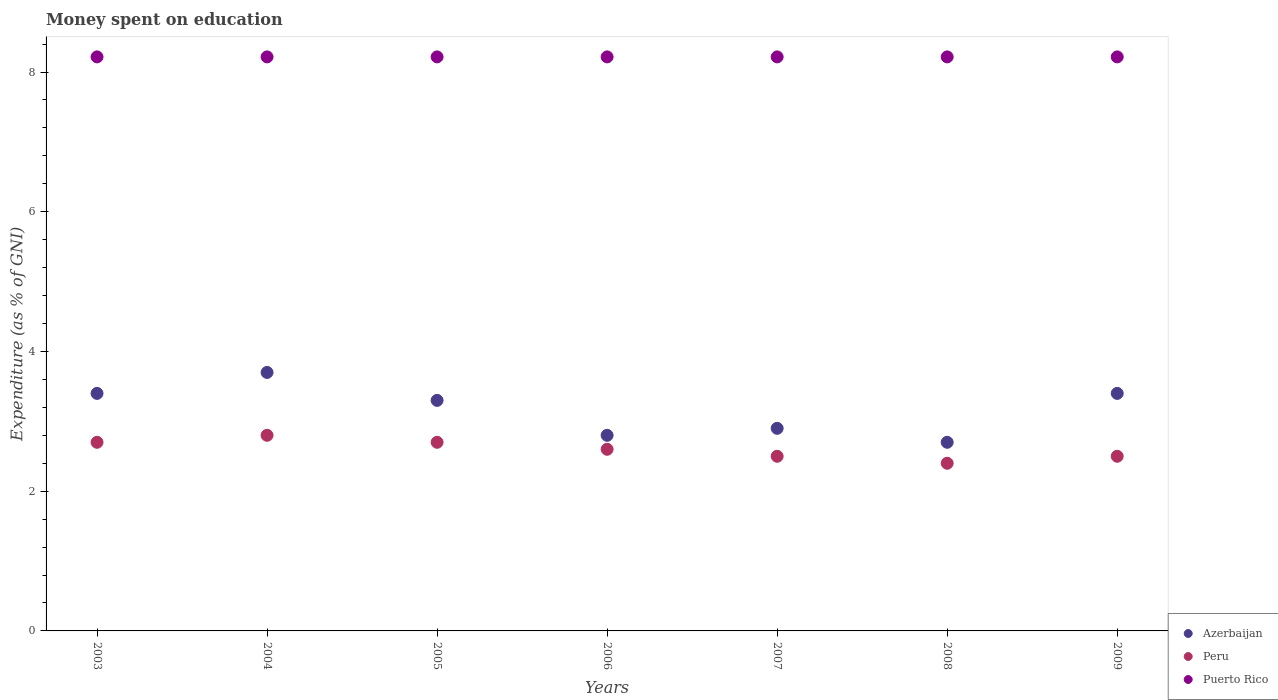Is the number of dotlines equal to the number of legend labels?
Make the answer very short. Yes. What is the amount of money spent on education in Puerto Rico in 2009?
Your answer should be compact. 8.22. Across all years, what is the maximum amount of money spent on education in Puerto Rico?
Your answer should be very brief. 8.22. Across all years, what is the minimum amount of money spent on education in Azerbaijan?
Your answer should be very brief. 2.7. In which year was the amount of money spent on education in Peru maximum?
Your answer should be compact. 2004. In which year was the amount of money spent on education in Azerbaijan minimum?
Your response must be concise. 2008. What is the difference between the amount of money spent on education in Azerbaijan in 2006 and the amount of money spent on education in Puerto Rico in 2003?
Provide a short and direct response. -5.42. What is the average amount of money spent on education in Puerto Rico per year?
Your answer should be very brief. 8.22. In the year 2007, what is the difference between the amount of money spent on education in Peru and amount of money spent on education in Puerto Rico?
Ensure brevity in your answer.  -5.72. In how many years, is the amount of money spent on education in Peru greater than 4.8 %?
Offer a terse response. 0. What is the ratio of the amount of money spent on education in Peru in 2004 to that in 2005?
Ensure brevity in your answer.  1.04. Is the difference between the amount of money spent on education in Peru in 2003 and 2008 greater than the difference between the amount of money spent on education in Puerto Rico in 2003 and 2008?
Provide a succinct answer. Yes. What is the difference between the highest and the second highest amount of money spent on education in Azerbaijan?
Ensure brevity in your answer.  0.3. What is the difference between the highest and the lowest amount of money spent on education in Peru?
Give a very brief answer. 0.4. Is the amount of money spent on education in Peru strictly greater than the amount of money spent on education in Azerbaijan over the years?
Make the answer very short. No. How many dotlines are there?
Offer a terse response. 3. How many years are there in the graph?
Offer a terse response. 7. What is the difference between two consecutive major ticks on the Y-axis?
Your answer should be very brief. 2. Are the values on the major ticks of Y-axis written in scientific E-notation?
Ensure brevity in your answer.  No. Does the graph contain any zero values?
Give a very brief answer. No. How many legend labels are there?
Provide a succinct answer. 3. What is the title of the graph?
Ensure brevity in your answer.  Money spent on education. Does "Finland" appear as one of the legend labels in the graph?
Your answer should be very brief. No. What is the label or title of the X-axis?
Ensure brevity in your answer.  Years. What is the label or title of the Y-axis?
Give a very brief answer. Expenditure (as % of GNI). What is the Expenditure (as % of GNI) in Peru in 2003?
Provide a short and direct response. 2.7. What is the Expenditure (as % of GNI) in Puerto Rico in 2003?
Provide a succinct answer. 8.22. What is the Expenditure (as % of GNI) in Puerto Rico in 2004?
Your response must be concise. 8.22. What is the Expenditure (as % of GNI) in Azerbaijan in 2005?
Your answer should be very brief. 3.3. What is the Expenditure (as % of GNI) of Peru in 2005?
Make the answer very short. 2.7. What is the Expenditure (as % of GNI) in Puerto Rico in 2005?
Ensure brevity in your answer.  8.22. What is the Expenditure (as % of GNI) in Peru in 2006?
Make the answer very short. 2.6. What is the Expenditure (as % of GNI) of Puerto Rico in 2006?
Provide a succinct answer. 8.22. What is the Expenditure (as % of GNI) of Peru in 2007?
Give a very brief answer. 2.5. What is the Expenditure (as % of GNI) in Puerto Rico in 2007?
Your answer should be very brief. 8.22. What is the Expenditure (as % of GNI) in Peru in 2008?
Ensure brevity in your answer.  2.4. What is the Expenditure (as % of GNI) of Puerto Rico in 2008?
Provide a succinct answer. 8.22. What is the Expenditure (as % of GNI) of Azerbaijan in 2009?
Keep it short and to the point. 3.4. What is the Expenditure (as % of GNI) of Peru in 2009?
Offer a terse response. 2.5. What is the Expenditure (as % of GNI) in Puerto Rico in 2009?
Ensure brevity in your answer.  8.22. Across all years, what is the maximum Expenditure (as % of GNI) of Azerbaijan?
Your response must be concise. 3.7. Across all years, what is the maximum Expenditure (as % of GNI) of Peru?
Keep it short and to the point. 2.8. Across all years, what is the maximum Expenditure (as % of GNI) of Puerto Rico?
Keep it short and to the point. 8.22. Across all years, what is the minimum Expenditure (as % of GNI) in Peru?
Give a very brief answer. 2.4. Across all years, what is the minimum Expenditure (as % of GNI) in Puerto Rico?
Keep it short and to the point. 8.22. What is the total Expenditure (as % of GNI) of Azerbaijan in the graph?
Your response must be concise. 22.2. What is the total Expenditure (as % of GNI) of Puerto Rico in the graph?
Provide a short and direct response. 57.52. What is the difference between the Expenditure (as % of GNI) in Azerbaijan in 2003 and that in 2004?
Your answer should be compact. -0.3. What is the difference between the Expenditure (as % of GNI) in Peru in 2003 and that in 2004?
Your answer should be very brief. -0.1. What is the difference between the Expenditure (as % of GNI) in Peru in 2003 and that in 2005?
Give a very brief answer. 0. What is the difference between the Expenditure (as % of GNI) in Puerto Rico in 2003 and that in 2005?
Your response must be concise. 0. What is the difference between the Expenditure (as % of GNI) of Peru in 2003 and that in 2006?
Provide a succinct answer. 0.1. What is the difference between the Expenditure (as % of GNI) of Puerto Rico in 2003 and that in 2006?
Give a very brief answer. 0. What is the difference between the Expenditure (as % of GNI) in Peru in 2003 and that in 2007?
Ensure brevity in your answer.  0.2. What is the difference between the Expenditure (as % of GNI) in Azerbaijan in 2003 and that in 2008?
Ensure brevity in your answer.  0.7. What is the difference between the Expenditure (as % of GNI) of Peru in 2003 and that in 2009?
Make the answer very short. 0.2. What is the difference between the Expenditure (as % of GNI) in Puerto Rico in 2003 and that in 2009?
Give a very brief answer. 0. What is the difference between the Expenditure (as % of GNI) of Peru in 2004 and that in 2005?
Your response must be concise. 0.1. What is the difference between the Expenditure (as % of GNI) of Azerbaijan in 2004 and that in 2006?
Your response must be concise. 0.9. What is the difference between the Expenditure (as % of GNI) of Peru in 2004 and that in 2007?
Your answer should be very brief. 0.3. What is the difference between the Expenditure (as % of GNI) of Puerto Rico in 2004 and that in 2007?
Your answer should be compact. 0. What is the difference between the Expenditure (as % of GNI) of Azerbaijan in 2004 and that in 2009?
Ensure brevity in your answer.  0.3. What is the difference between the Expenditure (as % of GNI) in Peru in 2004 and that in 2009?
Provide a succinct answer. 0.3. What is the difference between the Expenditure (as % of GNI) of Puerto Rico in 2004 and that in 2009?
Your answer should be compact. 0. What is the difference between the Expenditure (as % of GNI) of Peru in 2005 and that in 2006?
Provide a short and direct response. 0.1. What is the difference between the Expenditure (as % of GNI) of Azerbaijan in 2005 and that in 2007?
Keep it short and to the point. 0.4. What is the difference between the Expenditure (as % of GNI) of Peru in 2005 and that in 2007?
Ensure brevity in your answer.  0.2. What is the difference between the Expenditure (as % of GNI) of Puerto Rico in 2005 and that in 2007?
Make the answer very short. 0. What is the difference between the Expenditure (as % of GNI) in Azerbaijan in 2005 and that in 2008?
Your answer should be very brief. 0.6. What is the difference between the Expenditure (as % of GNI) of Peru in 2005 and that in 2008?
Your response must be concise. 0.3. What is the difference between the Expenditure (as % of GNI) of Puerto Rico in 2005 and that in 2008?
Make the answer very short. 0. What is the difference between the Expenditure (as % of GNI) of Peru in 2005 and that in 2009?
Keep it short and to the point. 0.2. What is the difference between the Expenditure (as % of GNI) in Puerto Rico in 2005 and that in 2009?
Keep it short and to the point. 0. What is the difference between the Expenditure (as % of GNI) of Peru in 2006 and that in 2007?
Give a very brief answer. 0.1. What is the difference between the Expenditure (as % of GNI) in Puerto Rico in 2006 and that in 2007?
Your answer should be very brief. 0. What is the difference between the Expenditure (as % of GNI) of Peru in 2006 and that in 2008?
Provide a succinct answer. 0.2. What is the difference between the Expenditure (as % of GNI) of Azerbaijan in 2006 and that in 2009?
Keep it short and to the point. -0.6. What is the difference between the Expenditure (as % of GNI) in Puerto Rico in 2006 and that in 2009?
Make the answer very short. 0. What is the difference between the Expenditure (as % of GNI) of Peru in 2007 and that in 2008?
Offer a very short reply. 0.1. What is the difference between the Expenditure (as % of GNI) of Peru in 2007 and that in 2009?
Your response must be concise. 0. What is the difference between the Expenditure (as % of GNI) of Peru in 2008 and that in 2009?
Offer a terse response. -0.1. What is the difference between the Expenditure (as % of GNI) in Azerbaijan in 2003 and the Expenditure (as % of GNI) in Puerto Rico in 2004?
Provide a short and direct response. -4.82. What is the difference between the Expenditure (as % of GNI) in Peru in 2003 and the Expenditure (as % of GNI) in Puerto Rico in 2004?
Keep it short and to the point. -5.52. What is the difference between the Expenditure (as % of GNI) of Azerbaijan in 2003 and the Expenditure (as % of GNI) of Peru in 2005?
Make the answer very short. 0.7. What is the difference between the Expenditure (as % of GNI) of Azerbaijan in 2003 and the Expenditure (as % of GNI) of Puerto Rico in 2005?
Provide a short and direct response. -4.82. What is the difference between the Expenditure (as % of GNI) of Peru in 2003 and the Expenditure (as % of GNI) of Puerto Rico in 2005?
Your answer should be very brief. -5.52. What is the difference between the Expenditure (as % of GNI) of Azerbaijan in 2003 and the Expenditure (as % of GNI) of Peru in 2006?
Offer a very short reply. 0.8. What is the difference between the Expenditure (as % of GNI) of Azerbaijan in 2003 and the Expenditure (as % of GNI) of Puerto Rico in 2006?
Offer a terse response. -4.82. What is the difference between the Expenditure (as % of GNI) in Peru in 2003 and the Expenditure (as % of GNI) in Puerto Rico in 2006?
Give a very brief answer. -5.52. What is the difference between the Expenditure (as % of GNI) of Azerbaijan in 2003 and the Expenditure (as % of GNI) of Peru in 2007?
Your response must be concise. 0.9. What is the difference between the Expenditure (as % of GNI) of Azerbaijan in 2003 and the Expenditure (as % of GNI) of Puerto Rico in 2007?
Your response must be concise. -4.82. What is the difference between the Expenditure (as % of GNI) of Peru in 2003 and the Expenditure (as % of GNI) of Puerto Rico in 2007?
Provide a short and direct response. -5.52. What is the difference between the Expenditure (as % of GNI) in Azerbaijan in 2003 and the Expenditure (as % of GNI) in Puerto Rico in 2008?
Offer a very short reply. -4.82. What is the difference between the Expenditure (as % of GNI) of Peru in 2003 and the Expenditure (as % of GNI) of Puerto Rico in 2008?
Offer a very short reply. -5.52. What is the difference between the Expenditure (as % of GNI) in Azerbaijan in 2003 and the Expenditure (as % of GNI) in Puerto Rico in 2009?
Give a very brief answer. -4.82. What is the difference between the Expenditure (as % of GNI) of Peru in 2003 and the Expenditure (as % of GNI) of Puerto Rico in 2009?
Provide a succinct answer. -5.52. What is the difference between the Expenditure (as % of GNI) of Azerbaijan in 2004 and the Expenditure (as % of GNI) of Peru in 2005?
Provide a succinct answer. 1. What is the difference between the Expenditure (as % of GNI) of Azerbaijan in 2004 and the Expenditure (as % of GNI) of Puerto Rico in 2005?
Your answer should be very brief. -4.52. What is the difference between the Expenditure (as % of GNI) in Peru in 2004 and the Expenditure (as % of GNI) in Puerto Rico in 2005?
Offer a very short reply. -5.42. What is the difference between the Expenditure (as % of GNI) of Azerbaijan in 2004 and the Expenditure (as % of GNI) of Peru in 2006?
Provide a short and direct response. 1.1. What is the difference between the Expenditure (as % of GNI) of Azerbaijan in 2004 and the Expenditure (as % of GNI) of Puerto Rico in 2006?
Give a very brief answer. -4.52. What is the difference between the Expenditure (as % of GNI) in Peru in 2004 and the Expenditure (as % of GNI) in Puerto Rico in 2006?
Your response must be concise. -5.42. What is the difference between the Expenditure (as % of GNI) in Azerbaijan in 2004 and the Expenditure (as % of GNI) in Puerto Rico in 2007?
Your answer should be very brief. -4.52. What is the difference between the Expenditure (as % of GNI) in Peru in 2004 and the Expenditure (as % of GNI) in Puerto Rico in 2007?
Ensure brevity in your answer.  -5.42. What is the difference between the Expenditure (as % of GNI) of Azerbaijan in 2004 and the Expenditure (as % of GNI) of Puerto Rico in 2008?
Give a very brief answer. -4.52. What is the difference between the Expenditure (as % of GNI) of Peru in 2004 and the Expenditure (as % of GNI) of Puerto Rico in 2008?
Make the answer very short. -5.42. What is the difference between the Expenditure (as % of GNI) of Azerbaijan in 2004 and the Expenditure (as % of GNI) of Peru in 2009?
Your answer should be compact. 1.2. What is the difference between the Expenditure (as % of GNI) of Azerbaijan in 2004 and the Expenditure (as % of GNI) of Puerto Rico in 2009?
Offer a very short reply. -4.52. What is the difference between the Expenditure (as % of GNI) of Peru in 2004 and the Expenditure (as % of GNI) of Puerto Rico in 2009?
Your answer should be very brief. -5.42. What is the difference between the Expenditure (as % of GNI) of Azerbaijan in 2005 and the Expenditure (as % of GNI) of Peru in 2006?
Keep it short and to the point. 0.7. What is the difference between the Expenditure (as % of GNI) of Azerbaijan in 2005 and the Expenditure (as % of GNI) of Puerto Rico in 2006?
Your response must be concise. -4.92. What is the difference between the Expenditure (as % of GNI) in Peru in 2005 and the Expenditure (as % of GNI) in Puerto Rico in 2006?
Your answer should be compact. -5.52. What is the difference between the Expenditure (as % of GNI) in Azerbaijan in 2005 and the Expenditure (as % of GNI) in Peru in 2007?
Provide a succinct answer. 0.8. What is the difference between the Expenditure (as % of GNI) of Azerbaijan in 2005 and the Expenditure (as % of GNI) of Puerto Rico in 2007?
Your response must be concise. -4.92. What is the difference between the Expenditure (as % of GNI) in Peru in 2005 and the Expenditure (as % of GNI) in Puerto Rico in 2007?
Ensure brevity in your answer.  -5.52. What is the difference between the Expenditure (as % of GNI) in Azerbaijan in 2005 and the Expenditure (as % of GNI) in Puerto Rico in 2008?
Provide a succinct answer. -4.92. What is the difference between the Expenditure (as % of GNI) in Peru in 2005 and the Expenditure (as % of GNI) in Puerto Rico in 2008?
Your response must be concise. -5.52. What is the difference between the Expenditure (as % of GNI) of Azerbaijan in 2005 and the Expenditure (as % of GNI) of Peru in 2009?
Your answer should be compact. 0.8. What is the difference between the Expenditure (as % of GNI) in Azerbaijan in 2005 and the Expenditure (as % of GNI) in Puerto Rico in 2009?
Keep it short and to the point. -4.92. What is the difference between the Expenditure (as % of GNI) of Peru in 2005 and the Expenditure (as % of GNI) of Puerto Rico in 2009?
Your answer should be very brief. -5.52. What is the difference between the Expenditure (as % of GNI) in Azerbaijan in 2006 and the Expenditure (as % of GNI) in Puerto Rico in 2007?
Your answer should be very brief. -5.42. What is the difference between the Expenditure (as % of GNI) in Peru in 2006 and the Expenditure (as % of GNI) in Puerto Rico in 2007?
Your answer should be very brief. -5.62. What is the difference between the Expenditure (as % of GNI) of Azerbaijan in 2006 and the Expenditure (as % of GNI) of Peru in 2008?
Provide a short and direct response. 0.4. What is the difference between the Expenditure (as % of GNI) of Azerbaijan in 2006 and the Expenditure (as % of GNI) of Puerto Rico in 2008?
Provide a succinct answer. -5.42. What is the difference between the Expenditure (as % of GNI) of Peru in 2006 and the Expenditure (as % of GNI) of Puerto Rico in 2008?
Offer a very short reply. -5.62. What is the difference between the Expenditure (as % of GNI) in Azerbaijan in 2006 and the Expenditure (as % of GNI) in Peru in 2009?
Keep it short and to the point. 0.3. What is the difference between the Expenditure (as % of GNI) of Azerbaijan in 2006 and the Expenditure (as % of GNI) of Puerto Rico in 2009?
Make the answer very short. -5.42. What is the difference between the Expenditure (as % of GNI) of Peru in 2006 and the Expenditure (as % of GNI) of Puerto Rico in 2009?
Offer a very short reply. -5.62. What is the difference between the Expenditure (as % of GNI) of Azerbaijan in 2007 and the Expenditure (as % of GNI) of Peru in 2008?
Provide a succinct answer. 0.5. What is the difference between the Expenditure (as % of GNI) in Azerbaijan in 2007 and the Expenditure (as % of GNI) in Puerto Rico in 2008?
Keep it short and to the point. -5.32. What is the difference between the Expenditure (as % of GNI) of Peru in 2007 and the Expenditure (as % of GNI) of Puerto Rico in 2008?
Make the answer very short. -5.72. What is the difference between the Expenditure (as % of GNI) of Azerbaijan in 2007 and the Expenditure (as % of GNI) of Puerto Rico in 2009?
Ensure brevity in your answer.  -5.32. What is the difference between the Expenditure (as % of GNI) in Peru in 2007 and the Expenditure (as % of GNI) in Puerto Rico in 2009?
Provide a short and direct response. -5.72. What is the difference between the Expenditure (as % of GNI) of Azerbaijan in 2008 and the Expenditure (as % of GNI) of Peru in 2009?
Keep it short and to the point. 0.2. What is the difference between the Expenditure (as % of GNI) in Azerbaijan in 2008 and the Expenditure (as % of GNI) in Puerto Rico in 2009?
Keep it short and to the point. -5.52. What is the difference between the Expenditure (as % of GNI) in Peru in 2008 and the Expenditure (as % of GNI) in Puerto Rico in 2009?
Give a very brief answer. -5.82. What is the average Expenditure (as % of GNI) of Azerbaijan per year?
Ensure brevity in your answer.  3.17. What is the average Expenditure (as % of GNI) of Puerto Rico per year?
Your answer should be compact. 8.22. In the year 2003, what is the difference between the Expenditure (as % of GNI) in Azerbaijan and Expenditure (as % of GNI) in Puerto Rico?
Your answer should be compact. -4.82. In the year 2003, what is the difference between the Expenditure (as % of GNI) in Peru and Expenditure (as % of GNI) in Puerto Rico?
Offer a very short reply. -5.52. In the year 2004, what is the difference between the Expenditure (as % of GNI) in Azerbaijan and Expenditure (as % of GNI) in Peru?
Provide a succinct answer. 0.9. In the year 2004, what is the difference between the Expenditure (as % of GNI) of Azerbaijan and Expenditure (as % of GNI) of Puerto Rico?
Your response must be concise. -4.52. In the year 2004, what is the difference between the Expenditure (as % of GNI) in Peru and Expenditure (as % of GNI) in Puerto Rico?
Your answer should be very brief. -5.42. In the year 2005, what is the difference between the Expenditure (as % of GNI) of Azerbaijan and Expenditure (as % of GNI) of Puerto Rico?
Provide a short and direct response. -4.92. In the year 2005, what is the difference between the Expenditure (as % of GNI) of Peru and Expenditure (as % of GNI) of Puerto Rico?
Offer a terse response. -5.52. In the year 2006, what is the difference between the Expenditure (as % of GNI) of Azerbaijan and Expenditure (as % of GNI) of Puerto Rico?
Make the answer very short. -5.42. In the year 2006, what is the difference between the Expenditure (as % of GNI) of Peru and Expenditure (as % of GNI) of Puerto Rico?
Offer a terse response. -5.62. In the year 2007, what is the difference between the Expenditure (as % of GNI) of Azerbaijan and Expenditure (as % of GNI) of Peru?
Give a very brief answer. 0.4. In the year 2007, what is the difference between the Expenditure (as % of GNI) of Azerbaijan and Expenditure (as % of GNI) of Puerto Rico?
Make the answer very short. -5.32. In the year 2007, what is the difference between the Expenditure (as % of GNI) in Peru and Expenditure (as % of GNI) in Puerto Rico?
Offer a very short reply. -5.72. In the year 2008, what is the difference between the Expenditure (as % of GNI) of Azerbaijan and Expenditure (as % of GNI) of Peru?
Offer a terse response. 0.3. In the year 2008, what is the difference between the Expenditure (as % of GNI) in Azerbaijan and Expenditure (as % of GNI) in Puerto Rico?
Your answer should be very brief. -5.52. In the year 2008, what is the difference between the Expenditure (as % of GNI) in Peru and Expenditure (as % of GNI) in Puerto Rico?
Your answer should be compact. -5.82. In the year 2009, what is the difference between the Expenditure (as % of GNI) of Azerbaijan and Expenditure (as % of GNI) of Puerto Rico?
Keep it short and to the point. -4.82. In the year 2009, what is the difference between the Expenditure (as % of GNI) in Peru and Expenditure (as % of GNI) in Puerto Rico?
Keep it short and to the point. -5.72. What is the ratio of the Expenditure (as % of GNI) in Azerbaijan in 2003 to that in 2004?
Offer a terse response. 0.92. What is the ratio of the Expenditure (as % of GNI) of Peru in 2003 to that in 2004?
Your answer should be very brief. 0.96. What is the ratio of the Expenditure (as % of GNI) of Azerbaijan in 2003 to that in 2005?
Ensure brevity in your answer.  1.03. What is the ratio of the Expenditure (as % of GNI) in Peru in 2003 to that in 2005?
Your answer should be very brief. 1. What is the ratio of the Expenditure (as % of GNI) of Puerto Rico in 2003 to that in 2005?
Offer a terse response. 1. What is the ratio of the Expenditure (as % of GNI) in Azerbaijan in 2003 to that in 2006?
Your answer should be compact. 1.21. What is the ratio of the Expenditure (as % of GNI) of Peru in 2003 to that in 2006?
Your answer should be very brief. 1.04. What is the ratio of the Expenditure (as % of GNI) of Azerbaijan in 2003 to that in 2007?
Keep it short and to the point. 1.17. What is the ratio of the Expenditure (as % of GNI) in Azerbaijan in 2003 to that in 2008?
Make the answer very short. 1.26. What is the ratio of the Expenditure (as % of GNI) in Peru in 2003 to that in 2008?
Provide a succinct answer. 1.12. What is the ratio of the Expenditure (as % of GNI) in Puerto Rico in 2003 to that in 2008?
Provide a short and direct response. 1. What is the ratio of the Expenditure (as % of GNI) in Azerbaijan in 2003 to that in 2009?
Keep it short and to the point. 1. What is the ratio of the Expenditure (as % of GNI) of Azerbaijan in 2004 to that in 2005?
Ensure brevity in your answer.  1.12. What is the ratio of the Expenditure (as % of GNI) in Peru in 2004 to that in 2005?
Ensure brevity in your answer.  1.04. What is the ratio of the Expenditure (as % of GNI) of Puerto Rico in 2004 to that in 2005?
Provide a succinct answer. 1. What is the ratio of the Expenditure (as % of GNI) in Azerbaijan in 2004 to that in 2006?
Provide a short and direct response. 1.32. What is the ratio of the Expenditure (as % of GNI) of Puerto Rico in 2004 to that in 2006?
Provide a succinct answer. 1. What is the ratio of the Expenditure (as % of GNI) of Azerbaijan in 2004 to that in 2007?
Provide a short and direct response. 1.28. What is the ratio of the Expenditure (as % of GNI) of Peru in 2004 to that in 2007?
Keep it short and to the point. 1.12. What is the ratio of the Expenditure (as % of GNI) of Puerto Rico in 2004 to that in 2007?
Provide a short and direct response. 1. What is the ratio of the Expenditure (as % of GNI) in Azerbaijan in 2004 to that in 2008?
Your answer should be very brief. 1.37. What is the ratio of the Expenditure (as % of GNI) in Peru in 2004 to that in 2008?
Offer a terse response. 1.17. What is the ratio of the Expenditure (as % of GNI) in Puerto Rico in 2004 to that in 2008?
Ensure brevity in your answer.  1. What is the ratio of the Expenditure (as % of GNI) in Azerbaijan in 2004 to that in 2009?
Make the answer very short. 1.09. What is the ratio of the Expenditure (as % of GNI) of Peru in 2004 to that in 2009?
Your response must be concise. 1.12. What is the ratio of the Expenditure (as % of GNI) of Puerto Rico in 2004 to that in 2009?
Offer a very short reply. 1. What is the ratio of the Expenditure (as % of GNI) of Azerbaijan in 2005 to that in 2006?
Make the answer very short. 1.18. What is the ratio of the Expenditure (as % of GNI) of Peru in 2005 to that in 2006?
Make the answer very short. 1.04. What is the ratio of the Expenditure (as % of GNI) of Azerbaijan in 2005 to that in 2007?
Provide a succinct answer. 1.14. What is the ratio of the Expenditure (as % of GNI) in Puerto Rico in 2005 to that in 2007?
Your answer should be very brief. 1. What is the ratio of the Expenditure (as % of GNI) in Azerbaijan in 2005 to that in 2008?
Make the answer very short. 1.22. What is the ratio of the Expenditure (as % of GNI) in Peru in 2005 to that in 2008?
Provide a short and direct response. 1.12. What is the ratio of the Expenditure (as % of GNI) in Azerbaijan in 2005 to that in 2009?
Your answer should be very brief. 0.97. What is the ratio of the Expenditure (as % of GNI) in Puerto Rico in 2005 to that in 2009?
Provide a short and direct response. 1. What is the ratio of the Expenditure (as % of GNI) in Azerbaijan in 2006 to that in 2007?
Provide a succinct answer. 0.97. What is the ratio of the Expenditure (as % of GNI) of Peru in 2006 to that in 2007?
Your answer should be very brief. 1.04. What is the ratio of the Expenditure (as % of GNI) of Puerto Rico in 2006 to that in 2007?
Provide a short and direct response. 1. What is the ratio of the Expenditure (as % of GNI) of Azerbaijan in 2006 to that in 2008?
Your response must be concise. 1.04. What is the ratio of the Expenditure (as % of GNI) of Peru in 2006 to that in 2008?
Give a very brief answer. 1.08. What is the ratio of the Expenditure (as % of GNI) of Azerbaijan in 2006 to that in 2009?
Your response must be concise. 0.82. What is the ratio of the Expenditure (as % of GNI) of Peru in 2006 to that in 2009?
Provide a succinct answer. 1.04. What is the ratio of the Expenditure (as % of GNI) of Azerbaijan in 2007 to that in 2008?
Ensure brevity in your answer.  1.07. What is the ratio of the Expenditure (as % of GNI) in Peru in 2007 to that in 2008?
Provide a short and direct response. 1.04. What is the ratio of the Expenditure (as % of GNI) in Azerbaijan in 2007 to that in 2009?
Your answer should be very brief. 0.85. What is the ratio of the Expenditure (as % of GNI) in Azerbaijan in 2008 to that in 2009?
Keep it short and to the point. 0.79. What is the ratio of the Expenditure (as % of GNI) in Peru in 2008 to that in 2009?
Keep it short and to the point. 0.96. What is the difference between the highest and the second highest Expenditure (as % of GNI) in Azerbaijan?
Provide a succinct answer. 0.3. What is the difference between the highest and the second highest Expenditure (as % of GNI) of Puerto Rico?
Your answer should be compact. 0. What is the difference between the highest and the lowest Expenditure (as % of GNI) in Azerbaijan?
Provide a succinct answer. 1. 